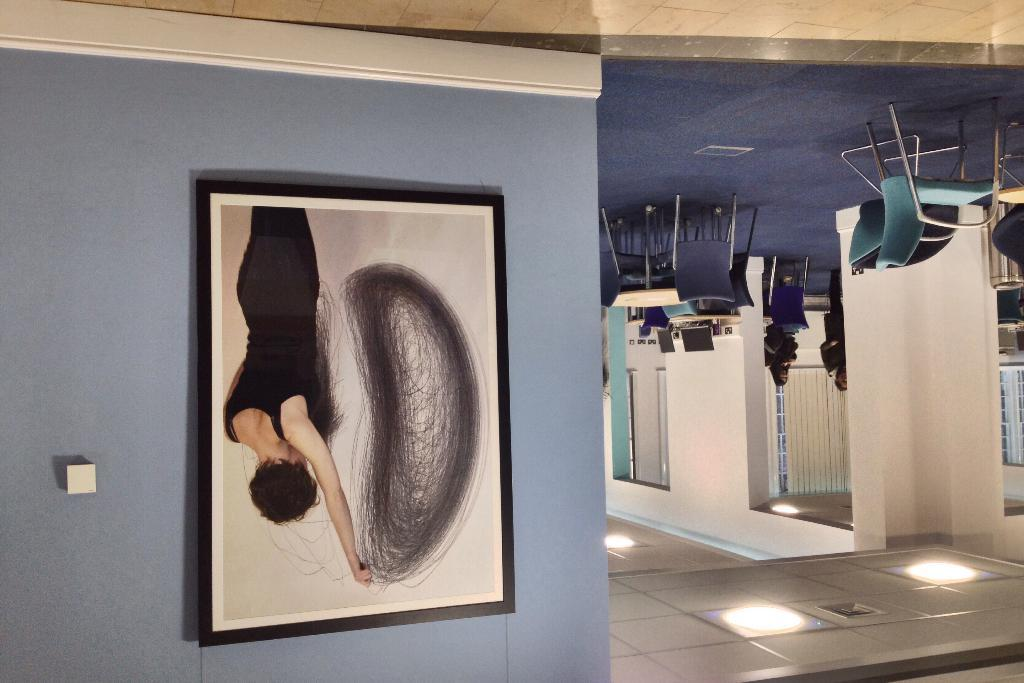What is the main structure in the image? There is a wall with a frame in the image. What can be seen inside the frame? There are objects in the frame. Who or what is present in the image? There are people in the image. What type of furniture is visible in the image? There are chairs in the image. Are there any openings in the wall? Yes, there are windows in the image. What else can be seen on the tables in the image? There are tables with objects in the image. What is the surface visible beneath the people and furniture? There is a ground visible in the image. What is present on the ground? There are lights on the ground. What type of flower is growing on the wall in the image? There is no flower growing on the wall in the image. Can you tell me how many hens are present in the image? There are no hens present in the image. What is the occupation of the secretary in the image? There is no secretary present in the image. 